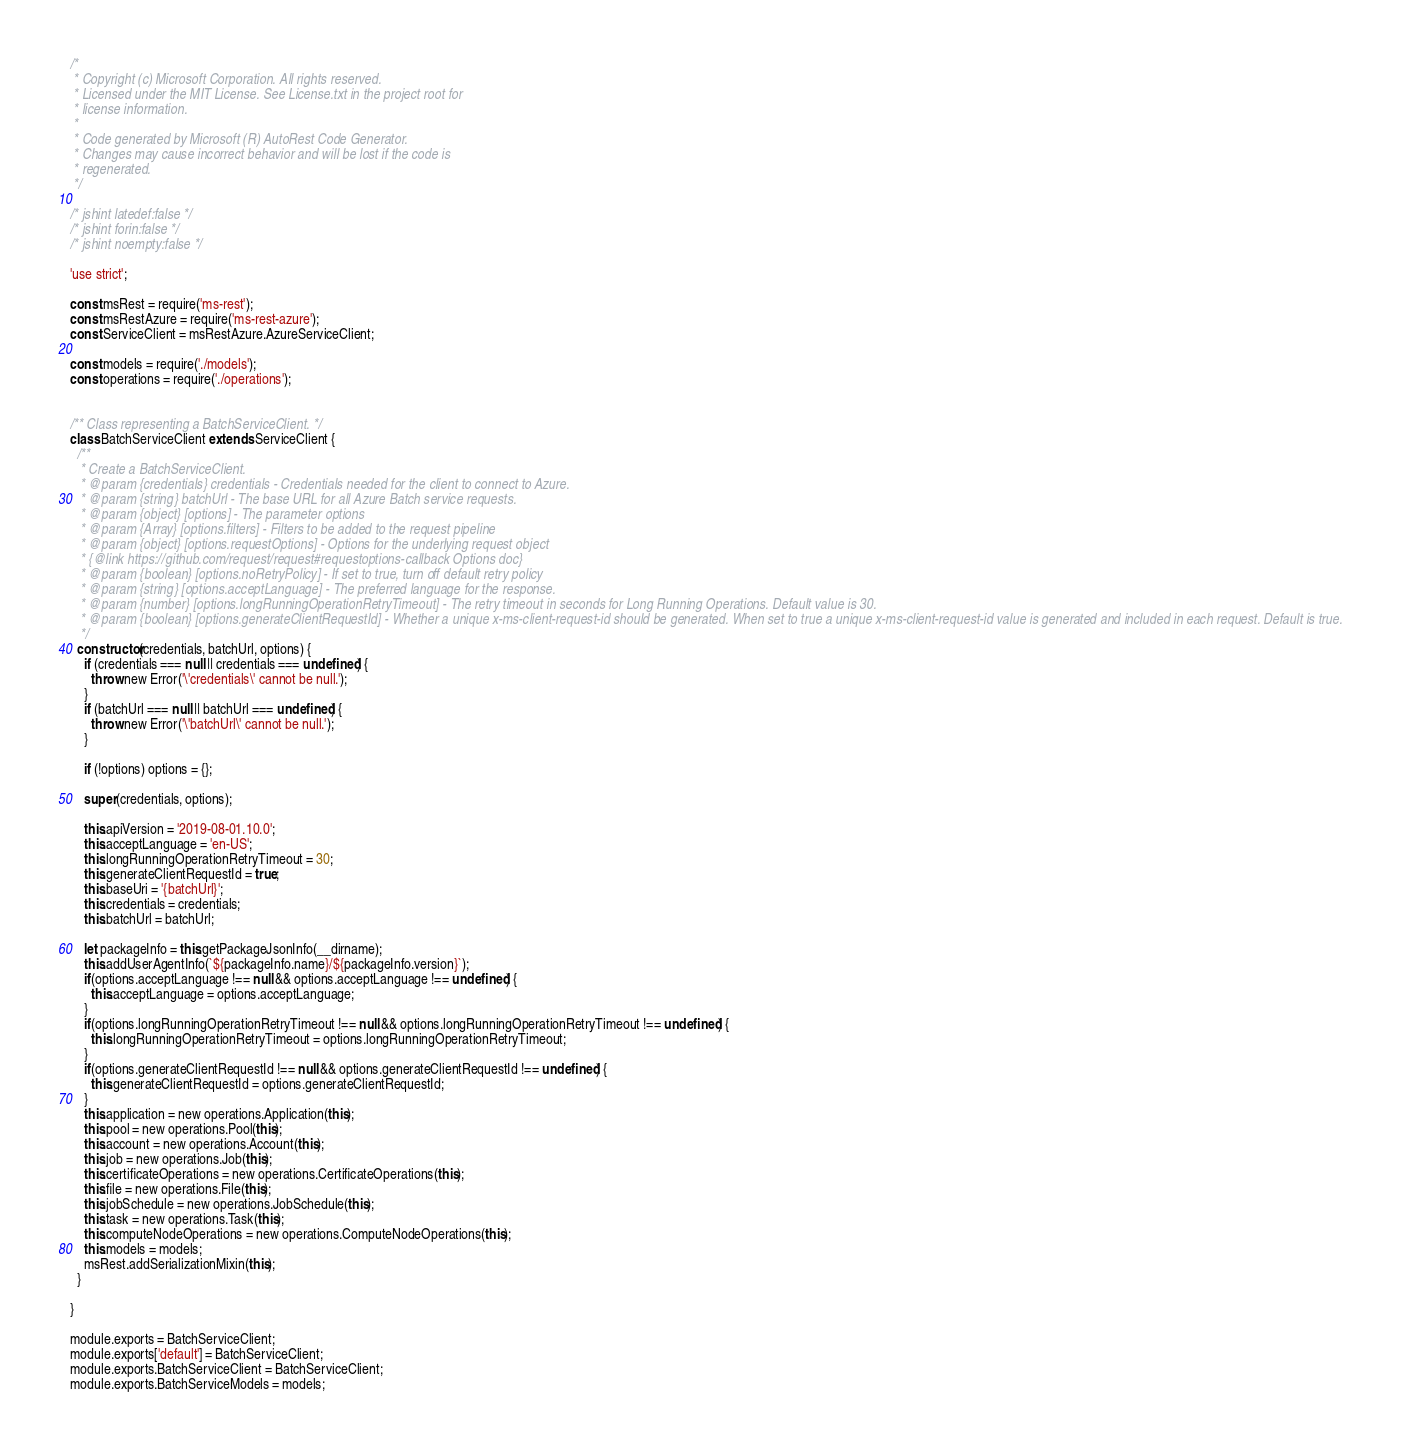<code> <loc_0><loc_0><loc_500><loc_500><_JavaScript_>/*
 * Copyright (c) Microsoft Corporation. All rights reserved.
 * Licensed under the MIT License. See License.txt in the project root for
 * license information.
 *
 * Code generated by Microsoft (R) AutoRest Code Generator.
 * Changes may cause incorrect behavior and will be lost if the code is
 * regenerated.
 */

/* jshint latedef:false */
/* jshint forin:false */
/* jshint noempty:false */

'use strict';

const msRest = require('ms-rest');
const msRestAzure = require('ms-rest-azure');
const ServiceClient = msRestAzure.AzureServiceClient;

const models = require('./models');
const operations = require('./operations');


/** Class representing a BatchServiceClient. */
class BatchServiceClient extends ServiceClient {
  /**
   * Create a BatchServiceClient.
   * @param {credentials} credentials - Credentials needed for the client to connect to Azure.
   * @param {string} batchUrl - The base URL for all Azure Batch service requests.
   * @param {object} [options] - The parameter options
   * @param {Array} [options.filters] - Filters to be added to the request pipeline
   * @param {object} [options.requestOptions] - Options for the underlying request object
   * {@link https://github.com/request/request#requestoptions-callback Options doc}
   * @param {boolean} [options.noRetryPolicy] - If set to true, turn off default retry policy
   * @param {string} [options.acceptLanguage] - The preferred language for the response.
   * @param {number} [options.longRunningOperationRetryTimeout] - The retry timeout in seconds for Long Running Operations. Default value is 30.
   * @param {boolean} [options.generateClientRequestId] - Whether a unique x-ms-client-request-id should be generated. When set to true a unique x-ms-client-request-id value is generated and included in each request. Default is true.
   */
  constructor(credentials, batchUrl, options) {
    if (credentials === null || credentials === undefined) {
      throw new Error('\'credentials\' cannot be null.');
    }
    if (batchUrl === null || batchUrl === undefined) {
      throw new Error('\'batchUrl\' cannot be null.');
    }

    if (!options) options = {};

    super(credentials, options);

    this.apiVersion = '2019-08-01.10.0';
    this.acceptLanguage = 'en-US';
    this.longRunningOperationRetryTimeout = 30;
    this.generateClientRequestId = true;
    this.baseUri = '{batchUrl}';
    this.credentials = credentials;
    this.batchUrl = batchUrl;

    let packageInfo = this.getPackageJsonInfo(__dirname);
    this.addUserAgentInfo(`${packageInfo.name}/${packageInfo.version}`);
    if(options.acceptLanguage !== null && options.acceptLanguage !== undefined) {
      this.acceptLanguage = options.acceptLanguage;
    }
    if(options.longRunningOperationRetryTimeout !== null && options.longRunningOperationRetryTimeout !== undefined) {
      this.longRunningOperationRetryTimeout = options.longRunningOperationRetryTimeout;
    }
    if(options.generateClientRequestId !== null && options.generateClientRequestId !== undefined) {
      this.generateClientRequestId = options.generateClientRequestId;
    }
    this.application = new operations.Application(this);
    this.pool = new operations.Pool(this);
    this.account = new operations.Account(this);
    this.job = new operations.Job(this);
    this.certificateOperations = new operations.CertificateOperations(this);
    this.file = new operations.File(this);
    this.jobSchedule = new operations.JobSchedule(this);
    this.task = new operations.Task(this);
    this.computeNodeOperations = new operations.ComputeNodeOperations(this);
    this.models = models;
    msRest.addSerializationMixin(this);
  }

}

module.exports = BatchServiceClient;
module.exports['default'] = BatchServiceClient;
module.exports.BatchServiceClient = BatchServiceClient;
module.exports.BatchServiceModels = models;
</code> 